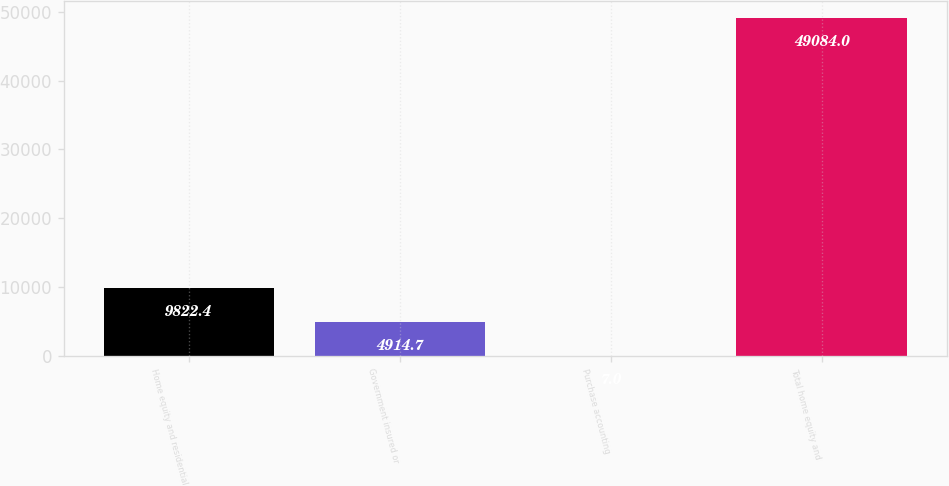<chart> <loc_0><loc_0><loc_500><loc_500><bar_chart><fcel>Home equity and residential<fcel>Government insured or<fcel>Purchase accounting<fcel>Total home equity and<nl><fcel>9822.4<fcel>4914.7<fcel>7<fcel>49084<nl></chart> 